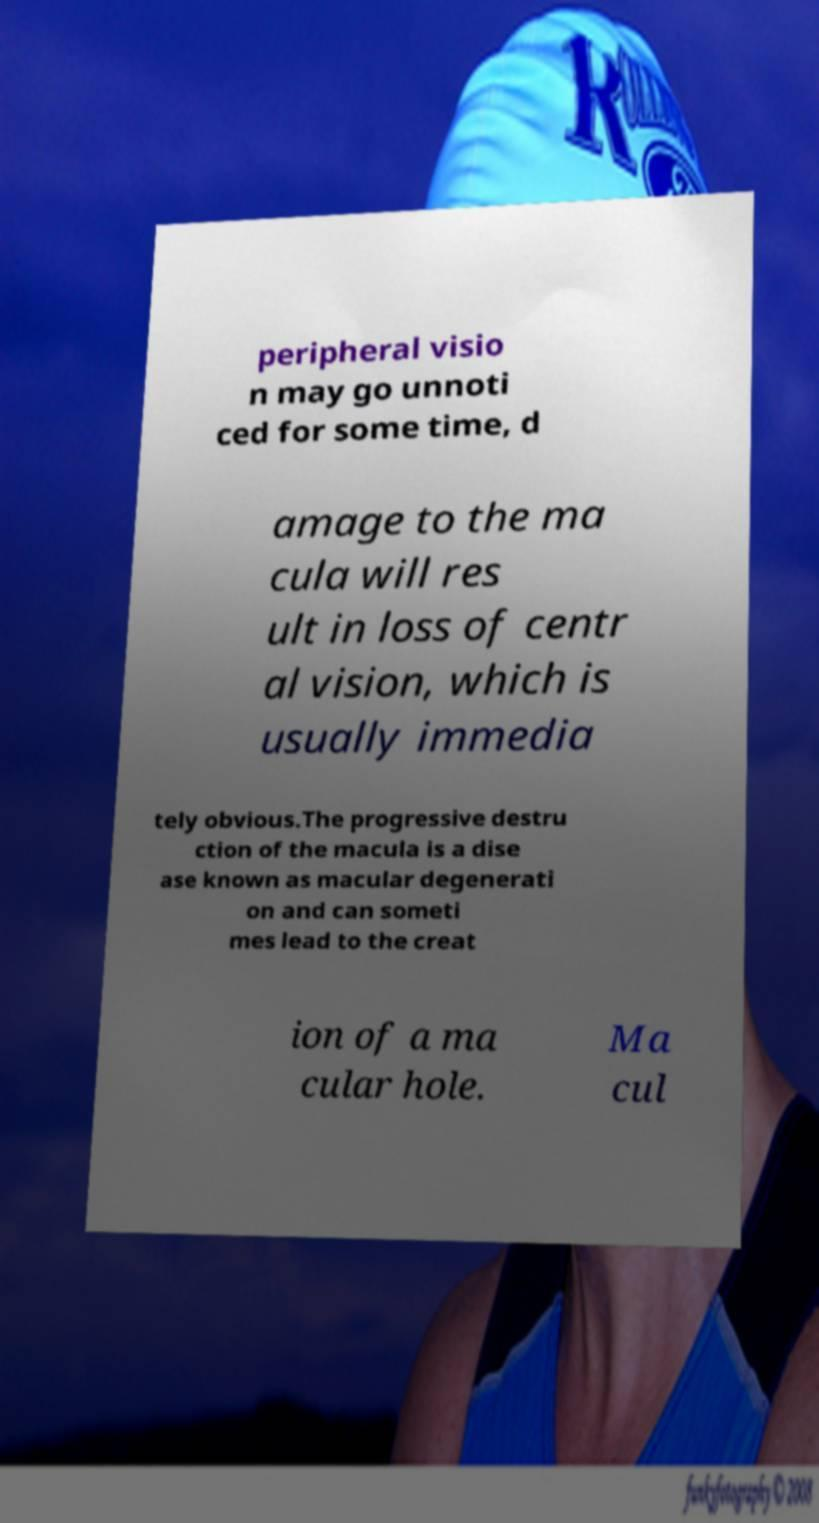Could you assist in decoding the text presented in this image and type it out clearly? peripheral visio n may go unnoti ced for some time, d amage to the ma cula will res ult in loss of centr al vision, which is usually immedia tely obvious.The progressive destru ction of the macula is a dise ase known as macular degenerati on and can someti mes lead to the creat ion of a ma cular hole. Ma cul 